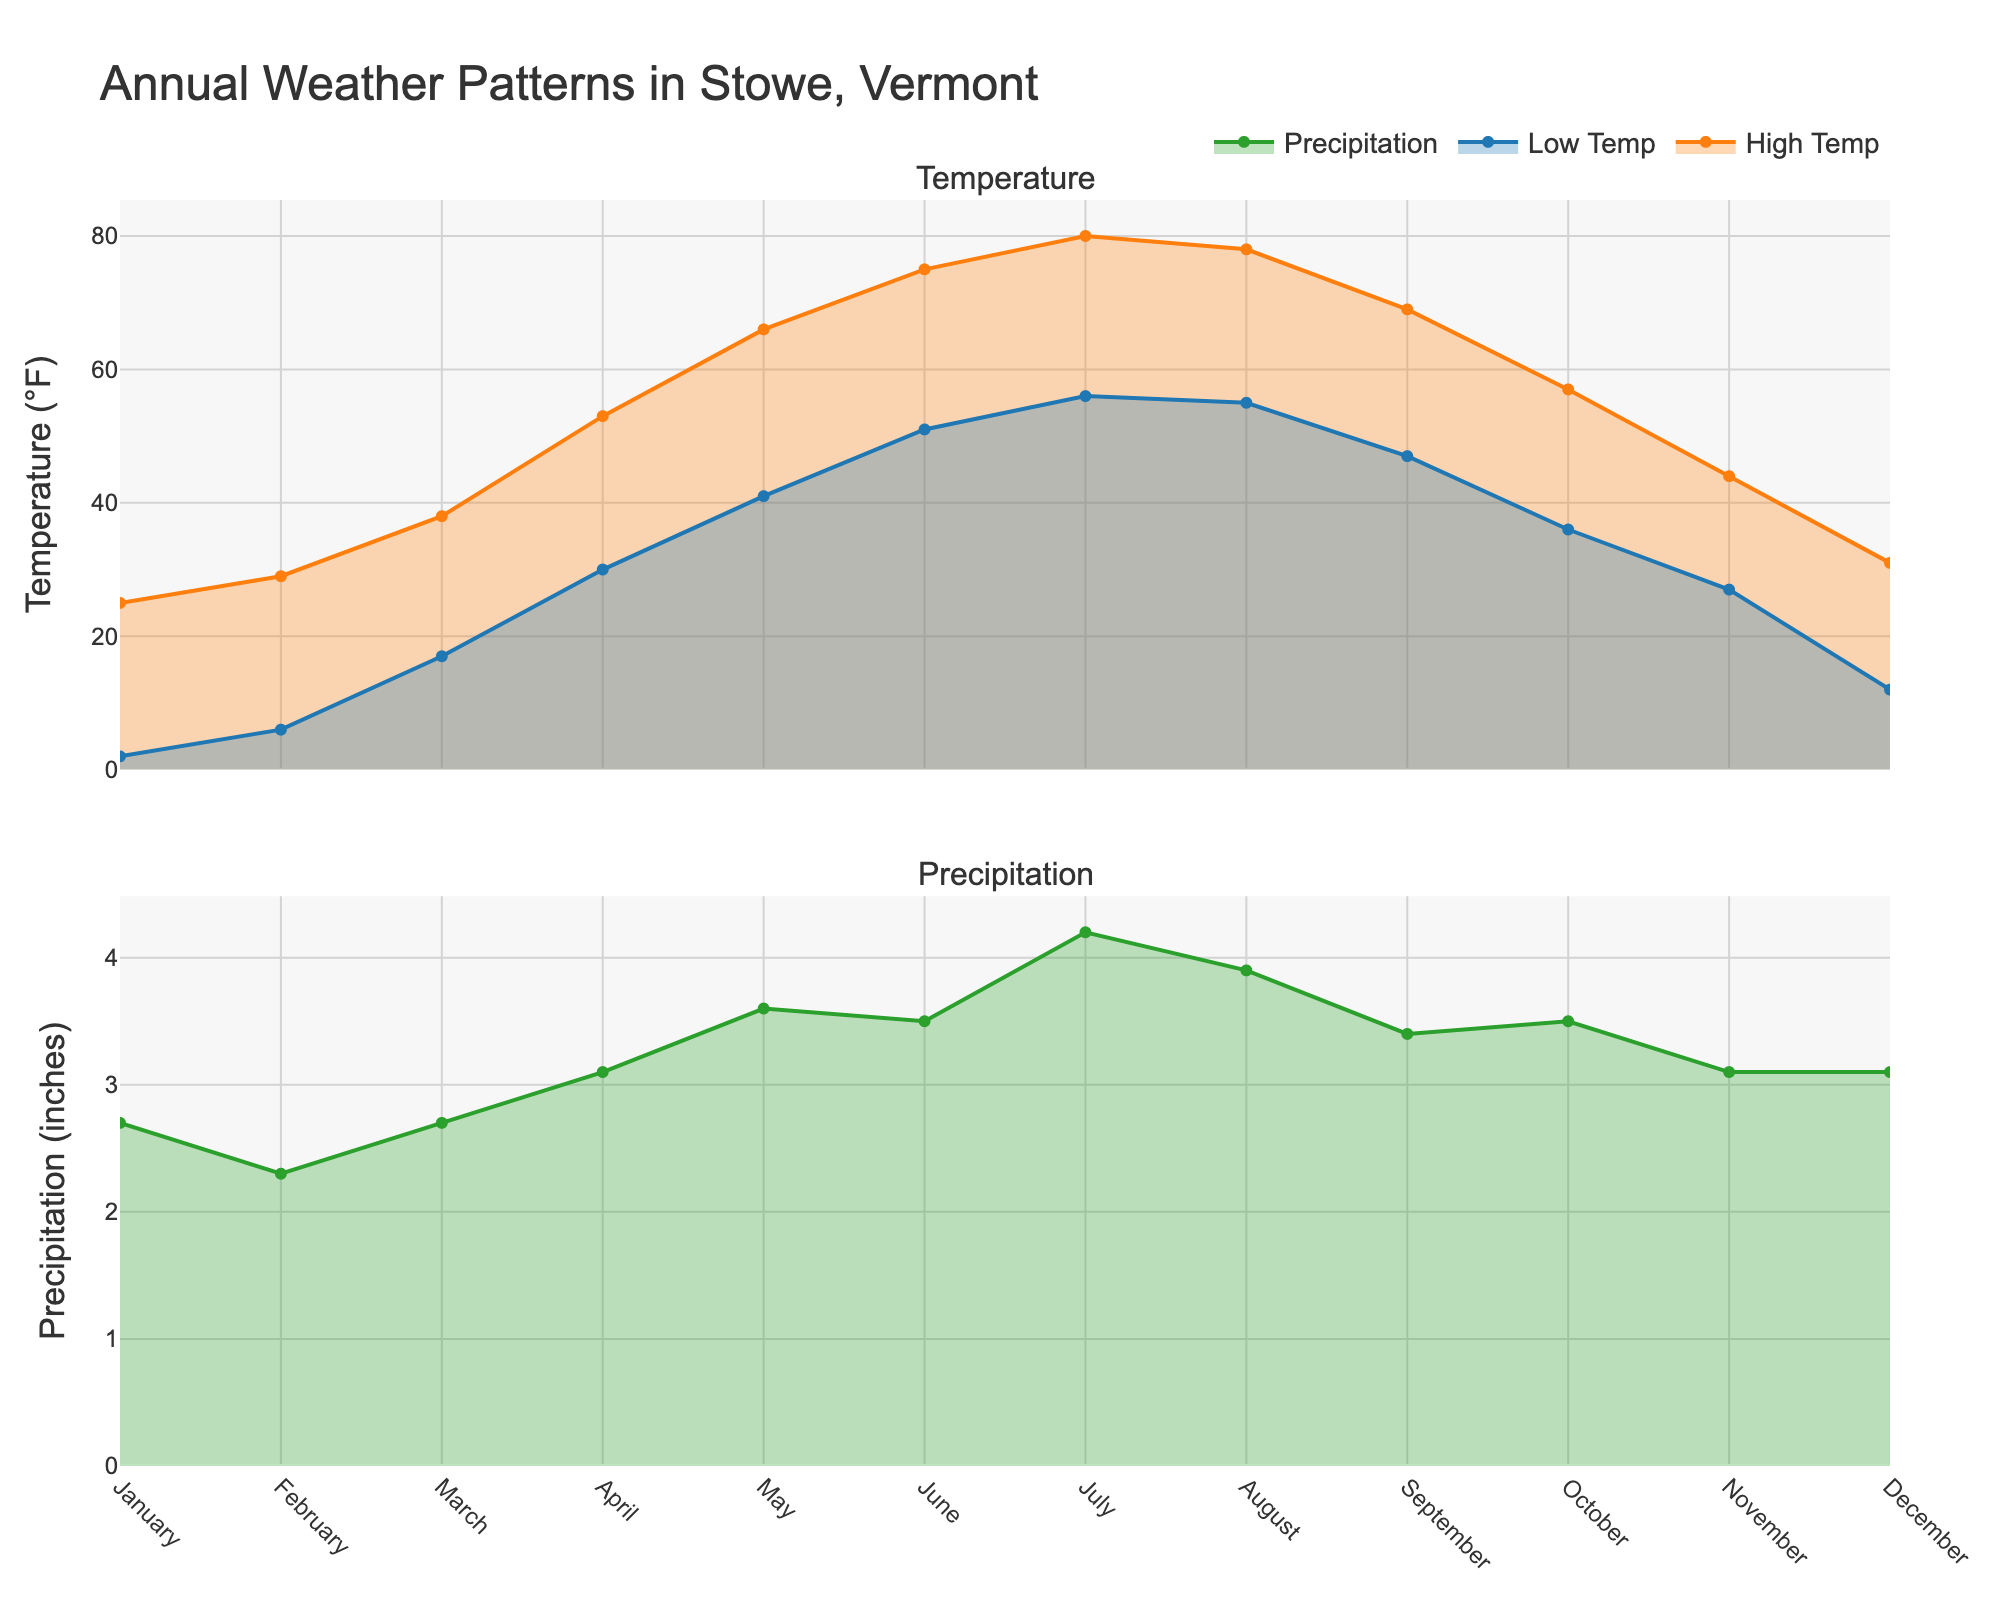What is the title of the figure? The title of the figure is displayed prominently at the top. It summarizes the data being presented in the two area charts.
Answer: Annual Weather Patterns in Stowe, Vermont How many subplots are present in the figure? By visually inspecting the figure, you can see that there are two distinct sections, one for Temperature and one for Precipitation.
Answer: 2 Which month experiences the highest average high temperature and what is it? By observing the peaks in the temperature area chart, you can see which month has the highest value for the "Average High Temperature".
Answer: July, 80°F Which months have average high temperatures below freezing? Compare the "Average High Temperature" values across all months and identify those below 32°F.
Answer: January, February, December What is the difference between the average high temperature in July and January? Look at the "Average High Temperature" for both July (80°F) and January (25°F) and calculate the difference.
Answer: 55°F Which month has the highest precipitation and what is the value? By examining the peaks in the precipitation area chart, identify the highest point.
Answer: July, 4.2 inches How does the average low temperature in August compare to the average high temperature in November? Compare the "Average Low Temperature" in August (55°F) with the "Average High Temperature" in November (44°F).
Answer: August's low temperature is higher than November's high temperature In which months is the precipitation less than 3 inches? Identify the months where the area under the precipitation graph is below the 3 inches line.
Answer: February, March What is the average low temperature in February and how does it compare to the average low temperature in December? Check the "Average Low Temperature" for February (6°F) and December (12°F) and compare them.
Answer: February's low is 6°F, December's low is higher at 12°F What are the average high temperatures for April and May? Look at the y-values for "Average High Temperature" in the months of April (53°F) and May (66°F).
Answer: April: 53°F, May: 66°F 